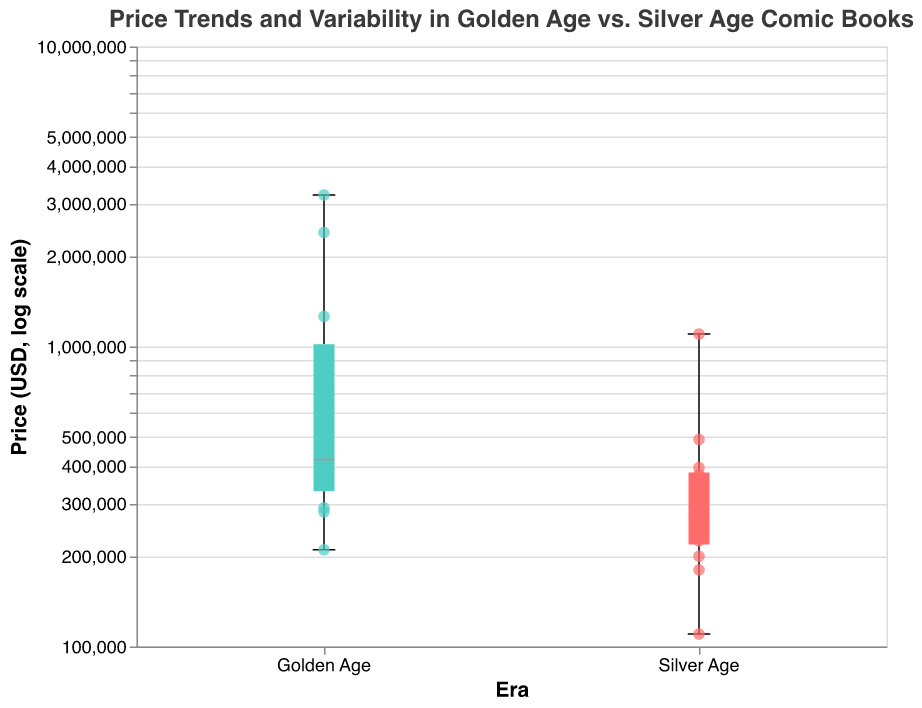What is the title of the figure? The title is written at the top, often in larger font size to draw attention. It serves as a brief description of what the figure is about.
Answer: Price Trends and Variability in Golden Age vs. Silver Age Comic Books Which era has the highest-priced comic book? The highest-priced comic book is represented by the highest box or point on the y-axis, which is labeled "Price (USD, log scale)". In the Golden Age, there is a point at 3,200,000 USD.
Answer: Golden Age What is the median price of Silver Age comic books? In a box plot, the median is indicated by a horizontal line within the box. For the Silver Age, the median line can be located by observing where it is within the box.
Answer: 275,000 USD Which comic book from the Golden Age has the lowest price, and what is it? This can be determined by examining the individual scatter points within the Golden Age box plot. The lowest point represents the comic book with the lowest price.
Answer: Wonder Woman #1, 210,000 USD How does the price variability compare between Golden Age and Silver Age comic books? Price variability is shown by the length of the box and the distance between the whiskers in a box plot. The Golden Age has a noticeably larger spread compared to the Silver Age.
Answer: The Golden Age has greater variability What is the interquartile range (IQR) of Golden Age comic books? The IQR is the distance between the first quartile (bottom of the box) and the third quartile (top of the box). This can be visually estimated within the box plot of the Golden Age.
Answer: Approximately 500,000 to 1,200,000 USD How many scatter points are there in the Silver Age category? Each scatter point represents a data point. By counting each point within the Silver Age box, we can find the total number.
Answer: 12 points Which era has more high-value outliers? Outliers are individual points that fall outside the whiskers. By counting any points outside the box and whiskers for each era, we can determine which has more high-value outliers.
Answer: Golden Age What is the price of "The Amazing Spider-Man #1" from the Silver Age? The specific prices are provided by the scatter points and tooltip. By identifying the relevant point in the Silver Age, the price can be extracted.
Answer: 1,100,000 USD 